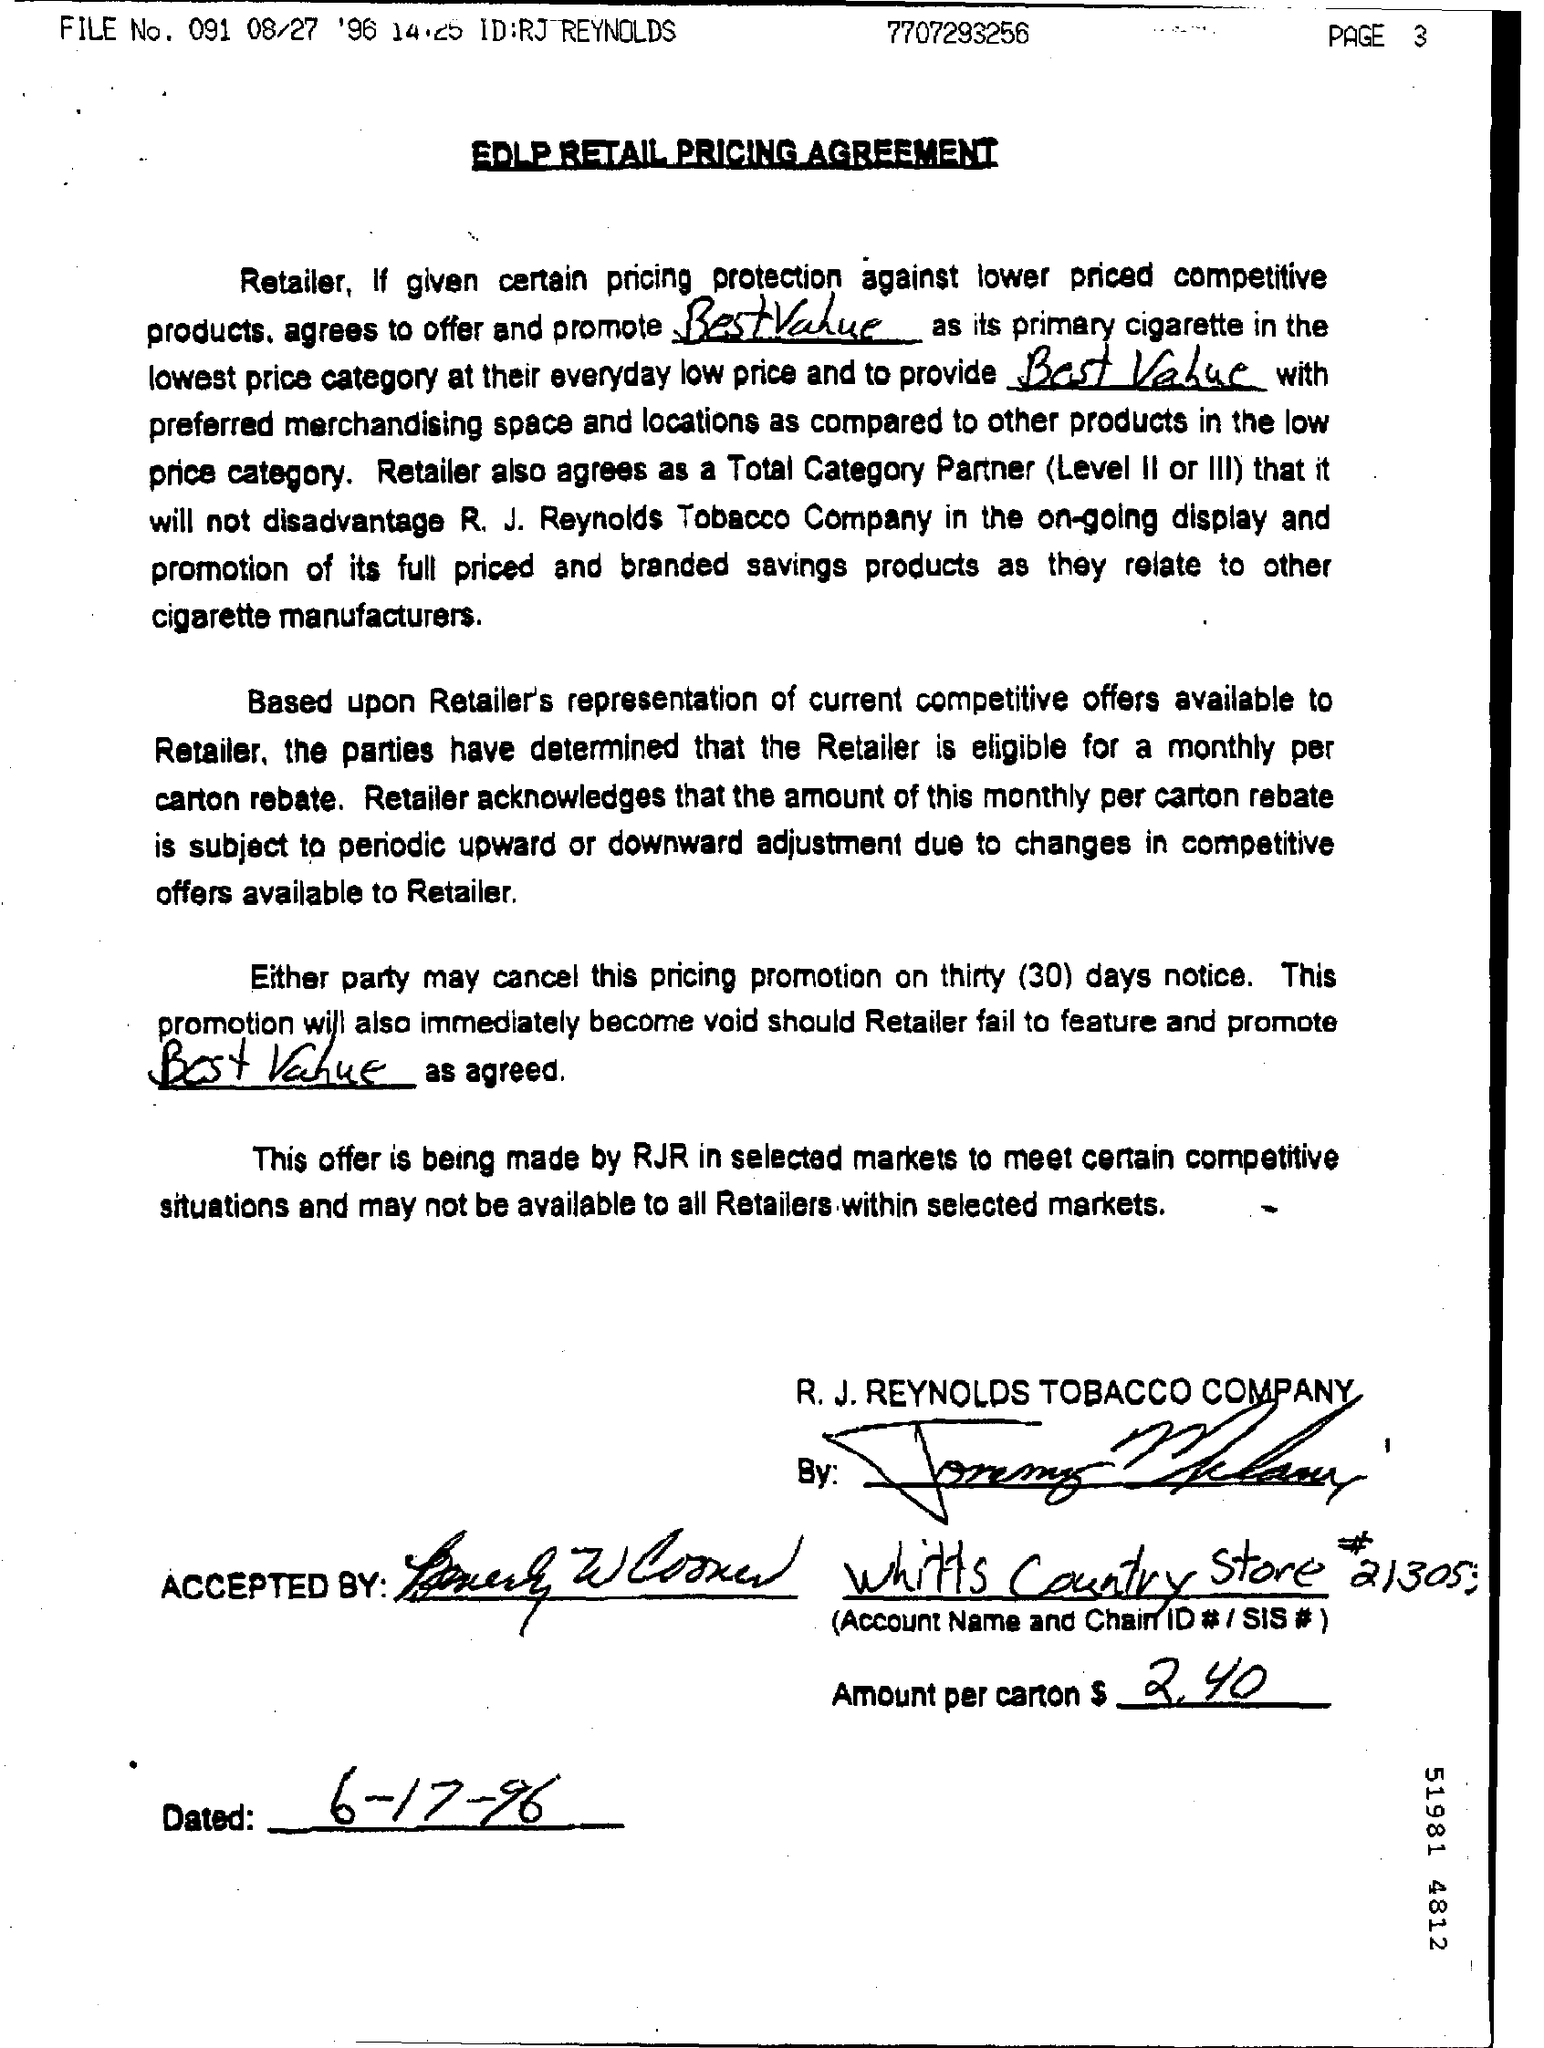Mention a couple of crucial points in this snapshot. The amount per carton is $2.40. On what date was the document dated? The document number is 7707293256... The title of the document is "EDLP RETAIL PRICING AGREEMENT. 